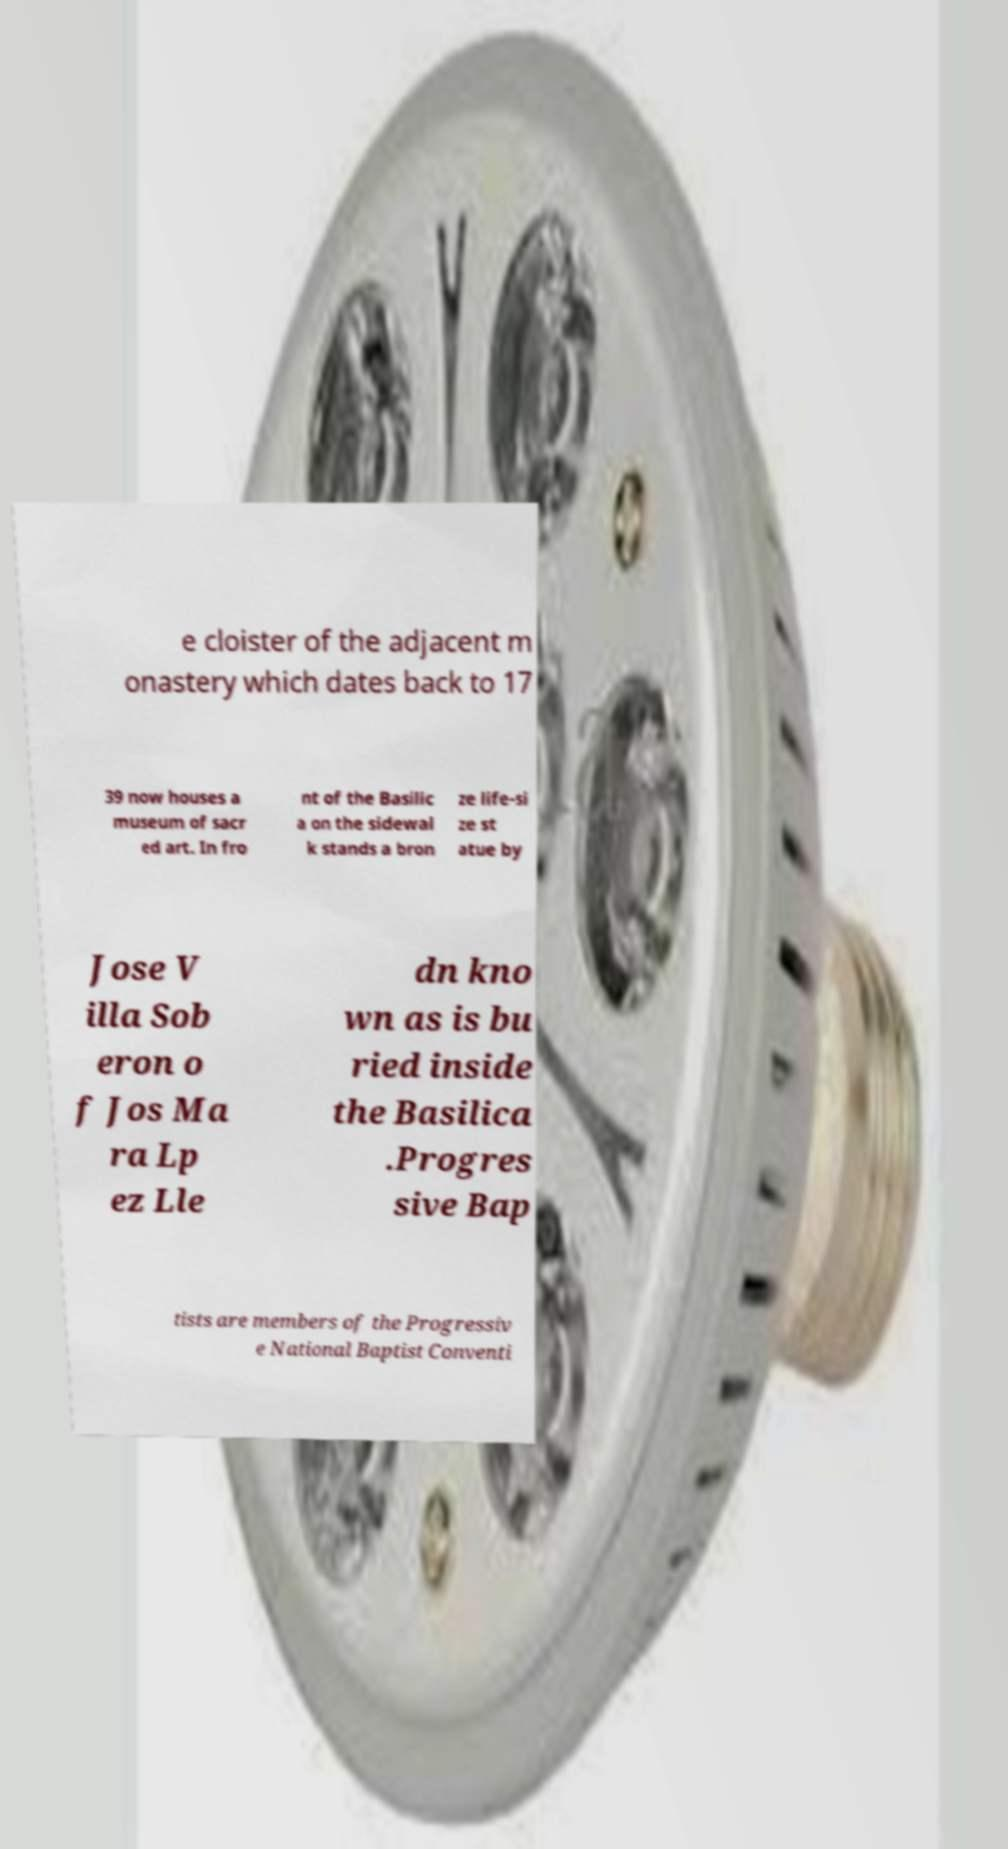Can you accurately transcribe the text from the provided image for me? e cloister of the adjacent m onastery which dates back to 17 39 now houses a museum of sacr ed art. In fro nt of the Basilic a on the sidewal k stands a bron ze life-si ze st atue by Jose V illa Sob eron o f Jos Ma ra Lp ez Lle dn kno wn as is bu ried inside the Basilica .Progres sive Bap tists are members of the Progressiv e National Baptist Conventi 